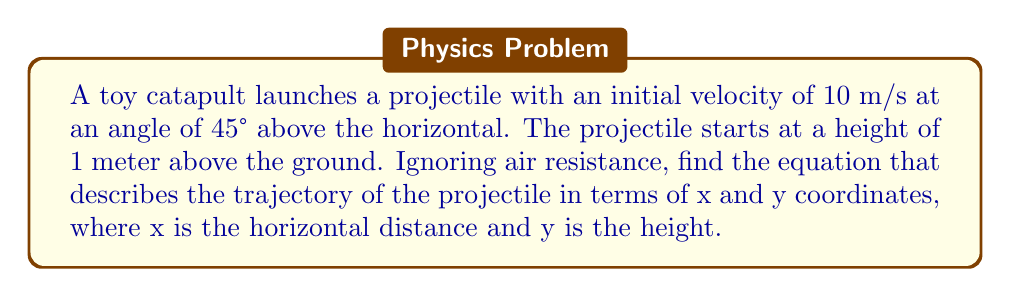Teach me how to tackle this problem. To find the trajectory equation, we'll follow these steps:

1. Identify the initial conditions:
   - Initial velocity: $v_0 = 10$ m/s
   - Launch angle: $\theta = 45°$
   - Initial height: $h_0 = 1$ m

2. Decompose the initial velocity into horizontal and vertical components:
   $v_{0x} = v_0 \cos(\theta) = 10 \cos(45°) = 10 \cdot \frac{\sqrt{2}}{2} \approx 7.07$ m/s
   $v_{0y} = v_0 \sin(\theta) = 10 \sin(45°) = 10 \cdot \frac{\sqrt{2}}{2} \approx 7.07$ m/s

3. Use the equations of motion for projectile motion:
   Horizontal motion: $x = v_{0x}t$
   Vertical motion: $y = h_0 + v_{0y}t - \frac{1}{2}gt^2$, where $g = 9.8$ m/s²

4. Eliminate time t from the equations:
   From horizontal motion: $t = \frac{x}{v_{0x}}$
   Substitute this into the vertical motion equation:
   $y = h_0 + v_{0y}(\frac{x}{v_{0x}}) - \frac{1}{2}g(\frac{x}{v_{0x}})^2$

5. Simplify and rearrange:
   $y = 1 + \frac{v_{0y}}{v_{0x}}x - \frac{g}{2(v_{0x})^2}x^2$
   $y = 1 + x - \frac{9.8}{2(7.07)^2}x^2$
   $y = 1 + x - 0.0981x^2$

Therefore, the equation of the trajectory is:
$$y = 1 + x - 0.0981x^2$$
Answer: $y = 1 + x - 0.0981x^2$ 